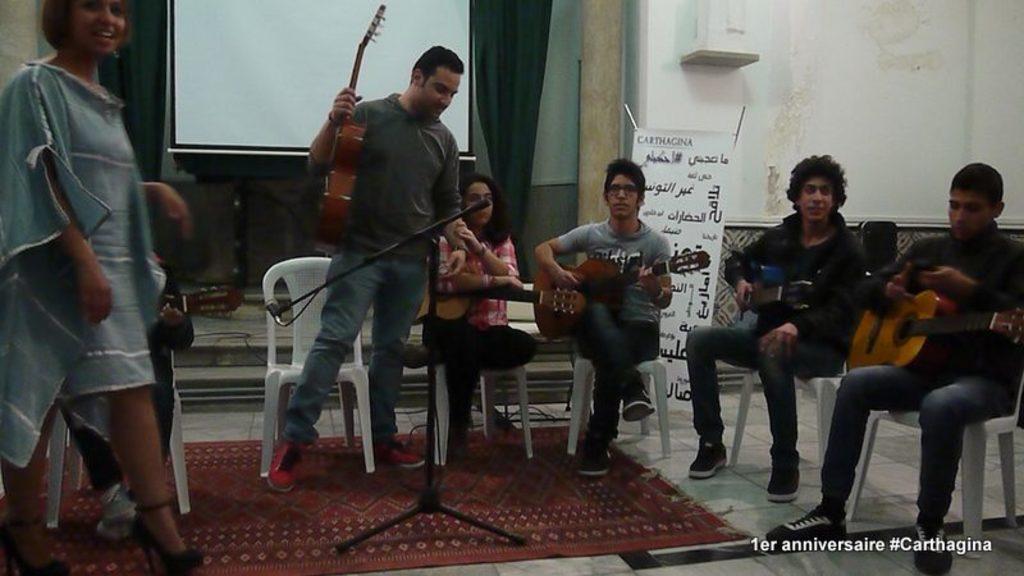How would you summarize this image in a sentence or two? In this image we can see some people in a room. We can see some people sitting and holding musical instruments. There is a banner with text on it and in the background, we can see a projector screen. 